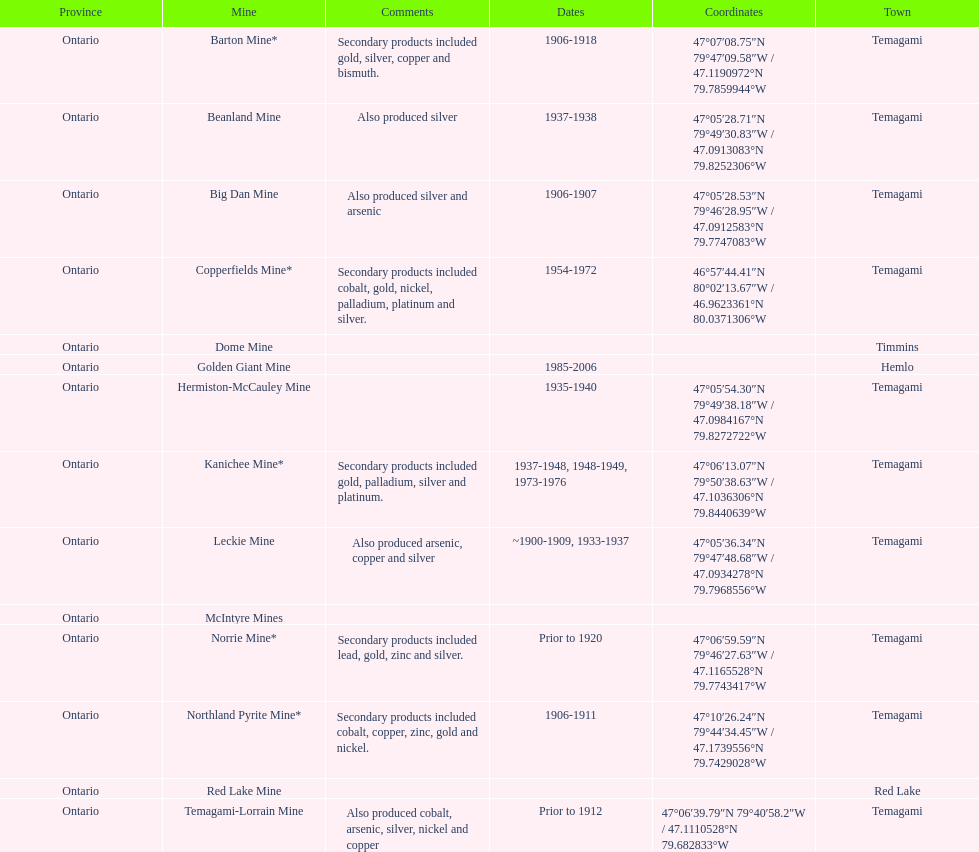How many times is temagami listedon the list? 10. 